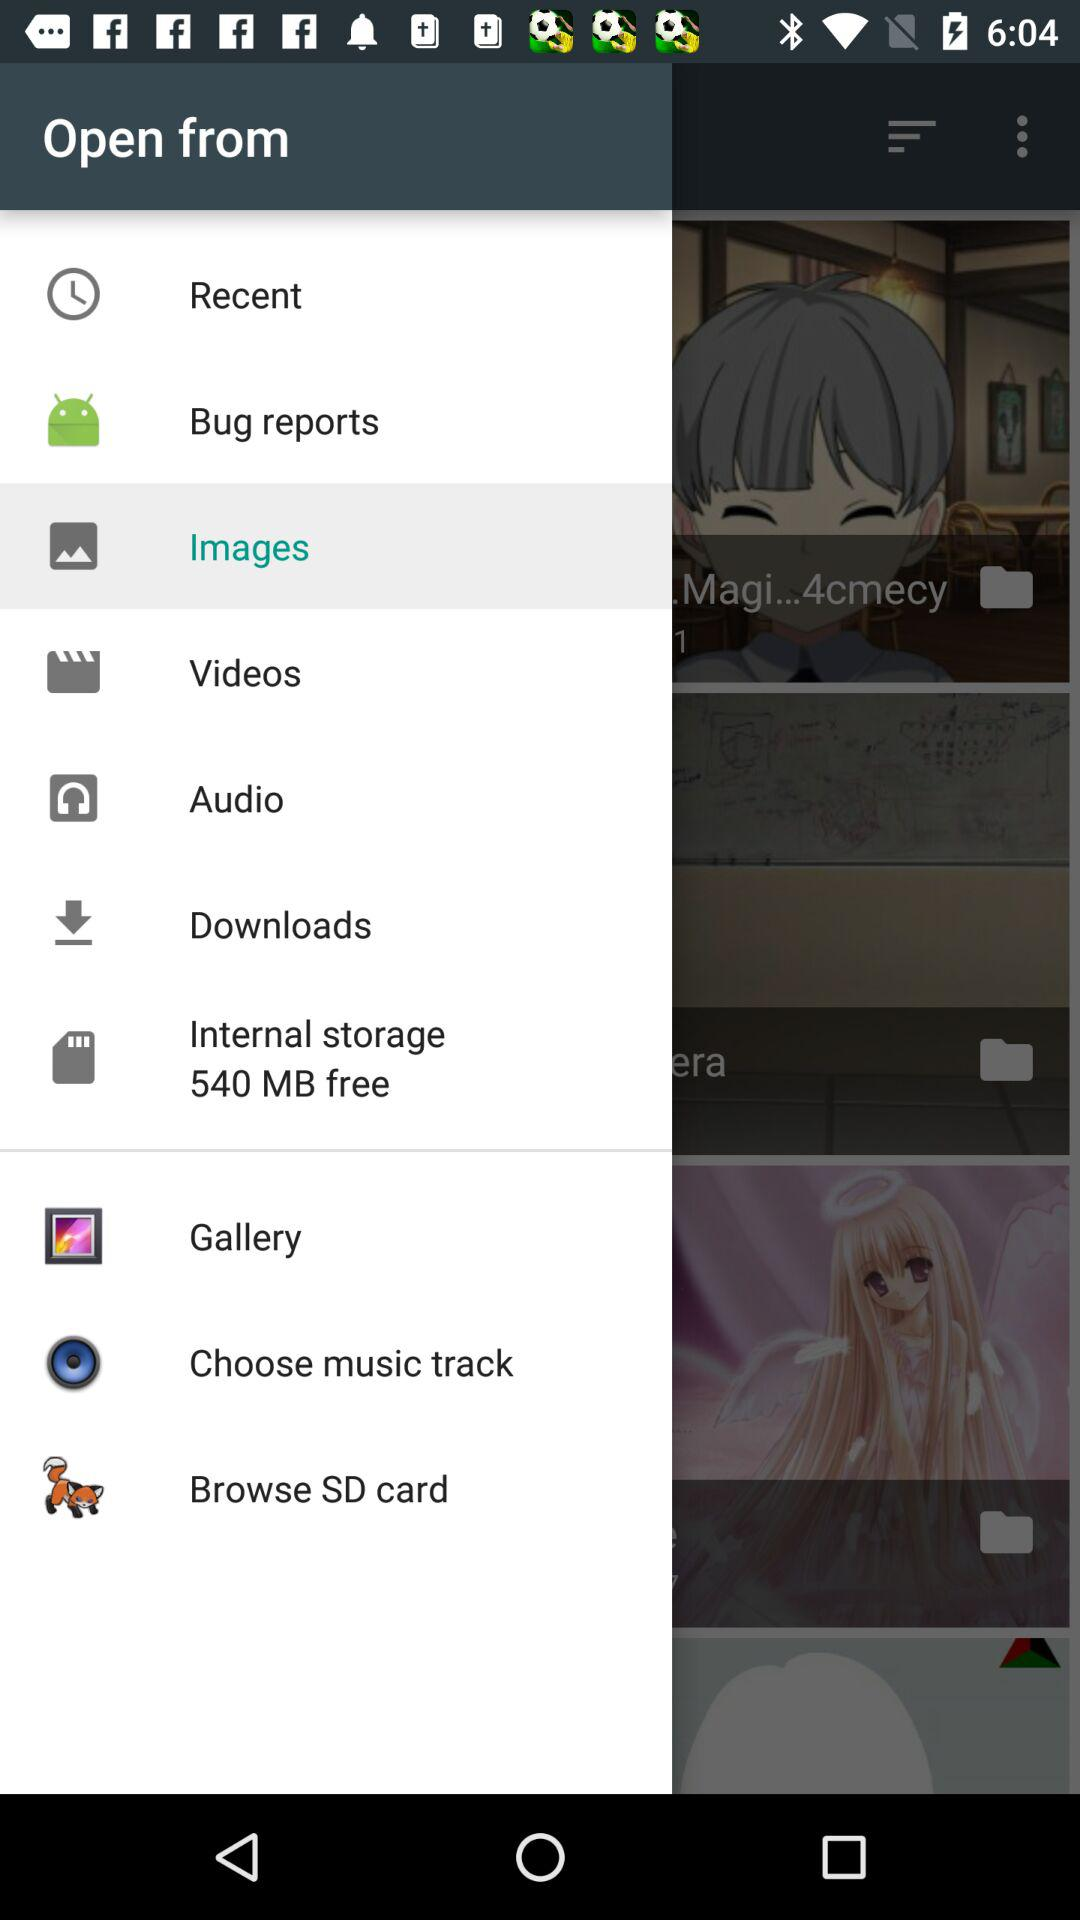Which item has been selected? The selected item is "Images". 